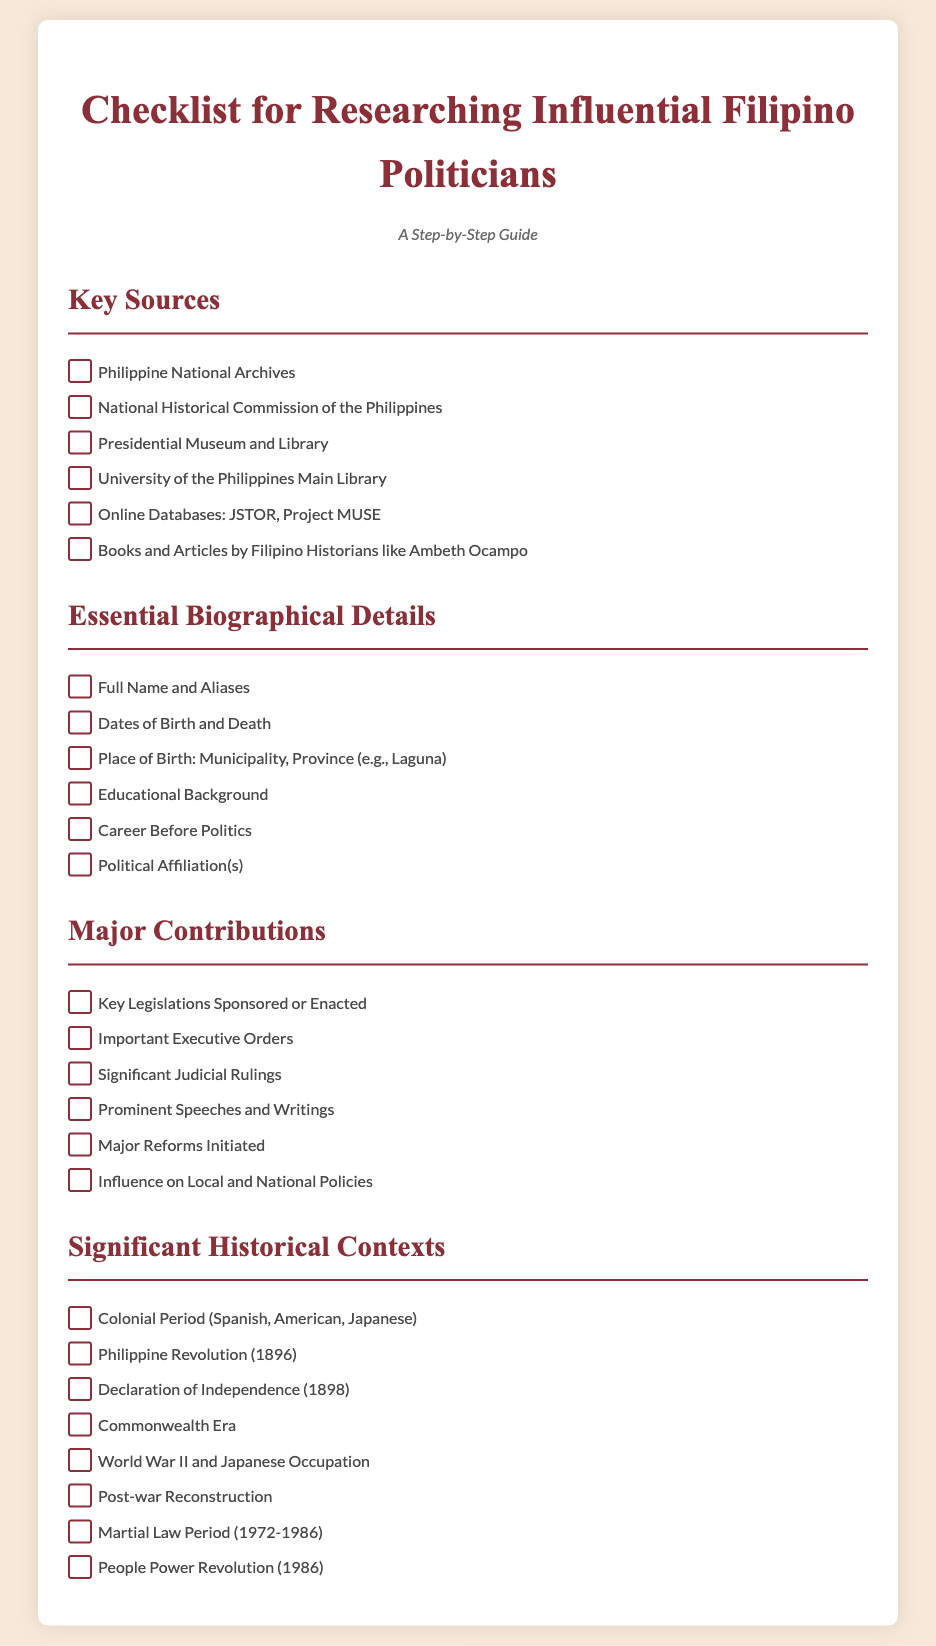What are the key sources listed? The key sources are specific organizations and databases referenced in the document for research, such as “Philippine National Archives” and “National Historical Commission of the Philippines.”
Answer: Philippine National Archives, National Historical Commission of the Philippines, Presidential Museum and Library, University of the Philippines Main Library, Online Databases: JSTOR, Project MUSE, Books and Articles by Filipino Historians like Ambeth Ocampo What is one essential biographical detail required? The document outlines various biographical details essential for researching politicians, one of which is “Full Name and Aliases.”
Answer: Full Name and Aliases How many significant historical contexts are mentioned? To answer this, we look for the number of historical contexts listed in the section provided in the document. There are eight listed contexts.
Answer: 8 What era is associated with the People Power Revolution? The People Power Revolution is identified in the document as occurring during the period from 1986.
Answer: 1986 What type of document is this checklist categorized as? This document is specifically titled as a “Checklist for Researching Influential Filipino Politicians,” indicating its type and purpose.
Answer: Checklist Which major reform initiatives are referenced? The document specifies “Major Reforms Initiated” as a category under “Major Contributions,” indicating it as a subject of interest.
Answer: Major Reforms Initiated 